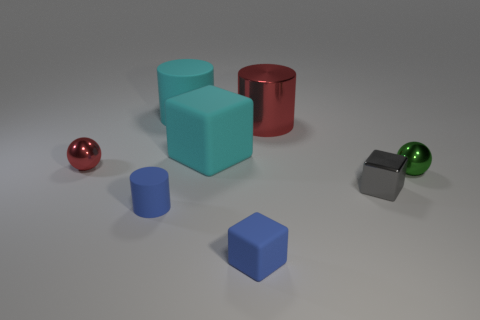Is the large red cylinder made of the same material as the tiny ball in front of the small red object?
Offer a very short reply. Yes. Are there any other things that have the same shape as the gray object?
Ensure brevity in your answer.  Yes. The cylinder that is to the left of the red cylinder and behind the red ball is what color?
Offer a terse response. Cyan. What shape is the small shiny object to the left of the metallic cube?
Offer a very short reply. Sphere. How big is the sphere that is in front of the ball that is left of the blue thing that is in front of the small matte cylinder?
Provide a succinct answer. Small. There is a sphere that is on the right side of the large red shiny cylinder; what number of blue matte blocks are left of it?
Your answer should be very brief. 1. There is a thing that is to the left of the big cyan cube and in front of the tiny red shiny thing; how big is it?
Make the answer very short. Small. How many rubber things are blue blocks or red balls?
Keep it short and to the point. 1. What is the material of the blue cube?
Keep it short and to the point. Rubber. What material is the blue thing that is right of the blue thing to the left of the object that is behind the big red cylinder?
Your response must be concise. Rubber. 